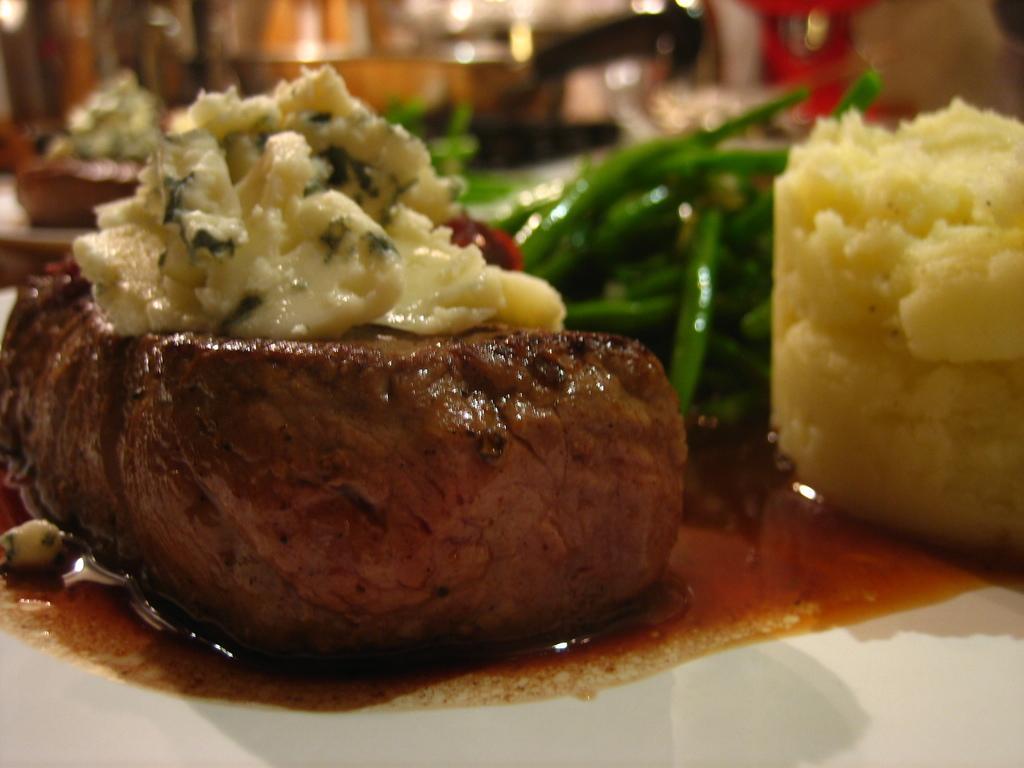In one or two sentences, can you explain what this image depicts? At the bottom of the image there is a plate, in the plate there is food. Behind the plate there are some glasses. Background of the image is blur. 